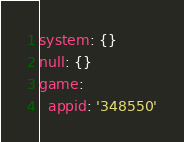Convert code to text. <code><loc_0><loc_0><loc_500><loc_500><_YAML_>system: {}
null: {}
game:
  appid: '348550'
</code> 